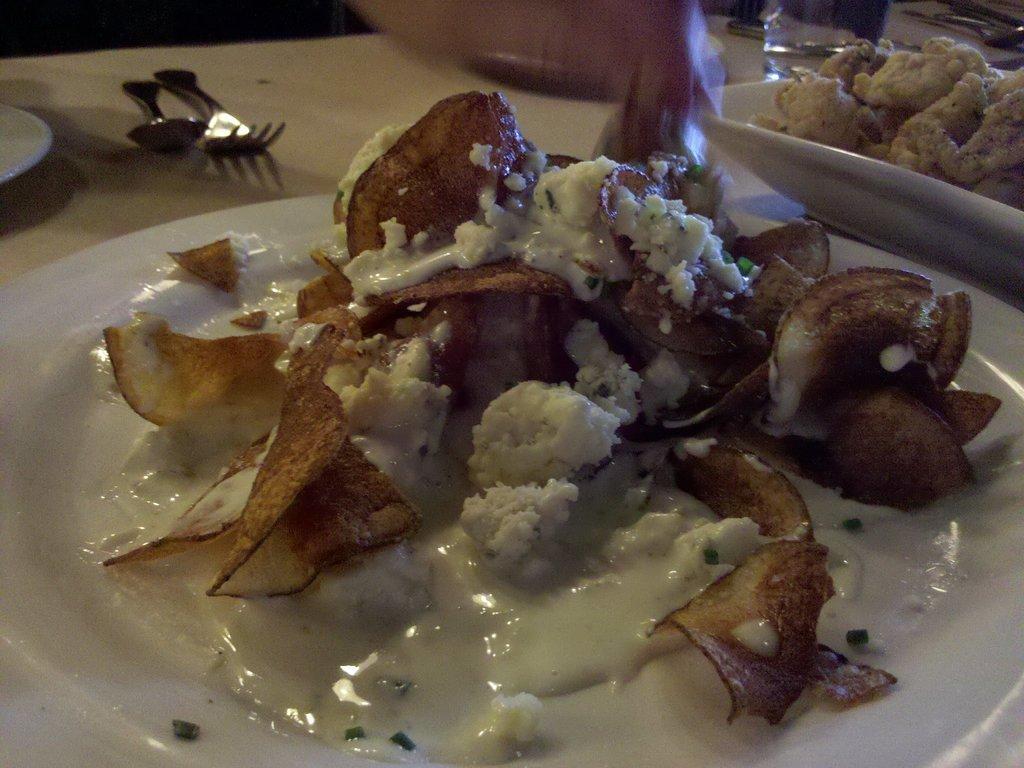In one or two sentences, can you explain what this image depicts? In this image I can see few plates, spoons, a glass, a fork and in these plates I can see different types of food. 